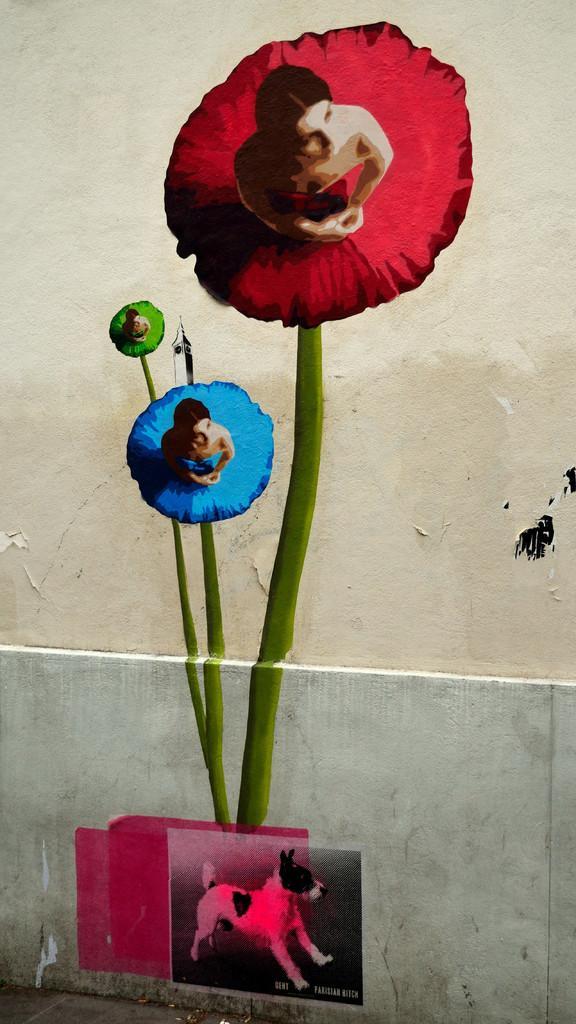Could you give a brief overview of what you see in this image? This picture shows painting on the wall and we see a dog and woman. 